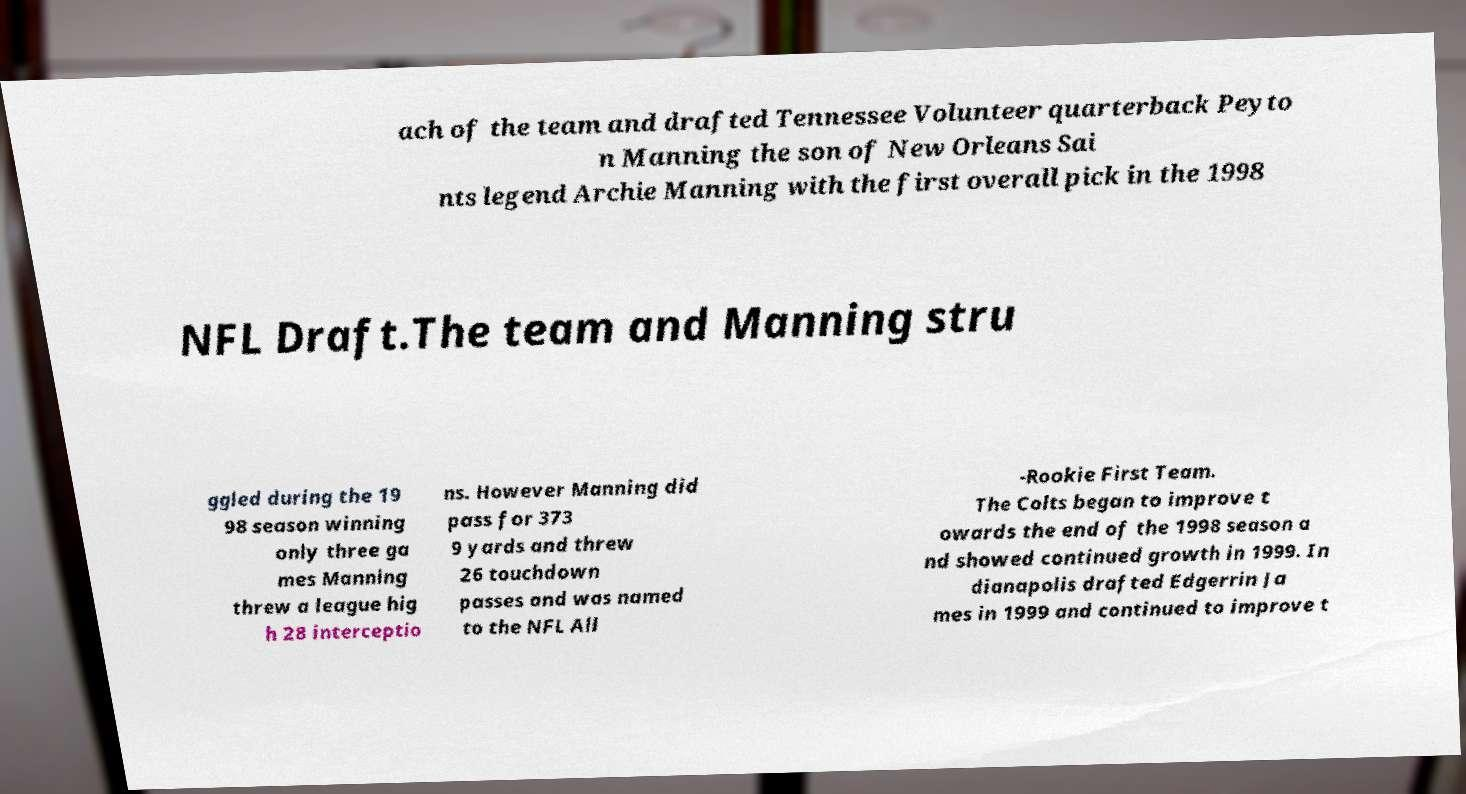Please identify and transcribe the text found in this image. ach of the team and drafted Tennessee Volunteer quarterback Peyto n Manning the son of New Orleans Sai nts legend Archie Manning with the first overall pick in the 1998 NFL Draft.The team and Manning stru ggled during the 19 98 season winning only three ga mes Manning threw a league hig h 28 interceptio ns. However Manning did pass for 373 9 yards and threw 26 touchdown passes and was named to the NFL All -Rookie First Team. The Colts began to improve t owards the end of the 1998 season a nd showed continued growth in 1999. In dianapolis drafted Edgerrin Ja mes in 1999 and continued to improve t 